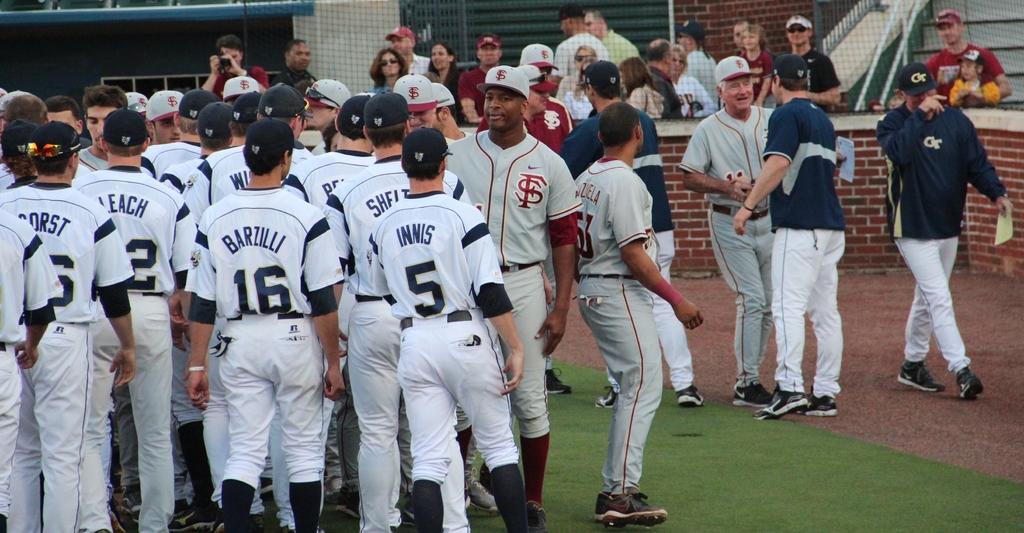What number is innis?
Give a very brief answer. 5. 